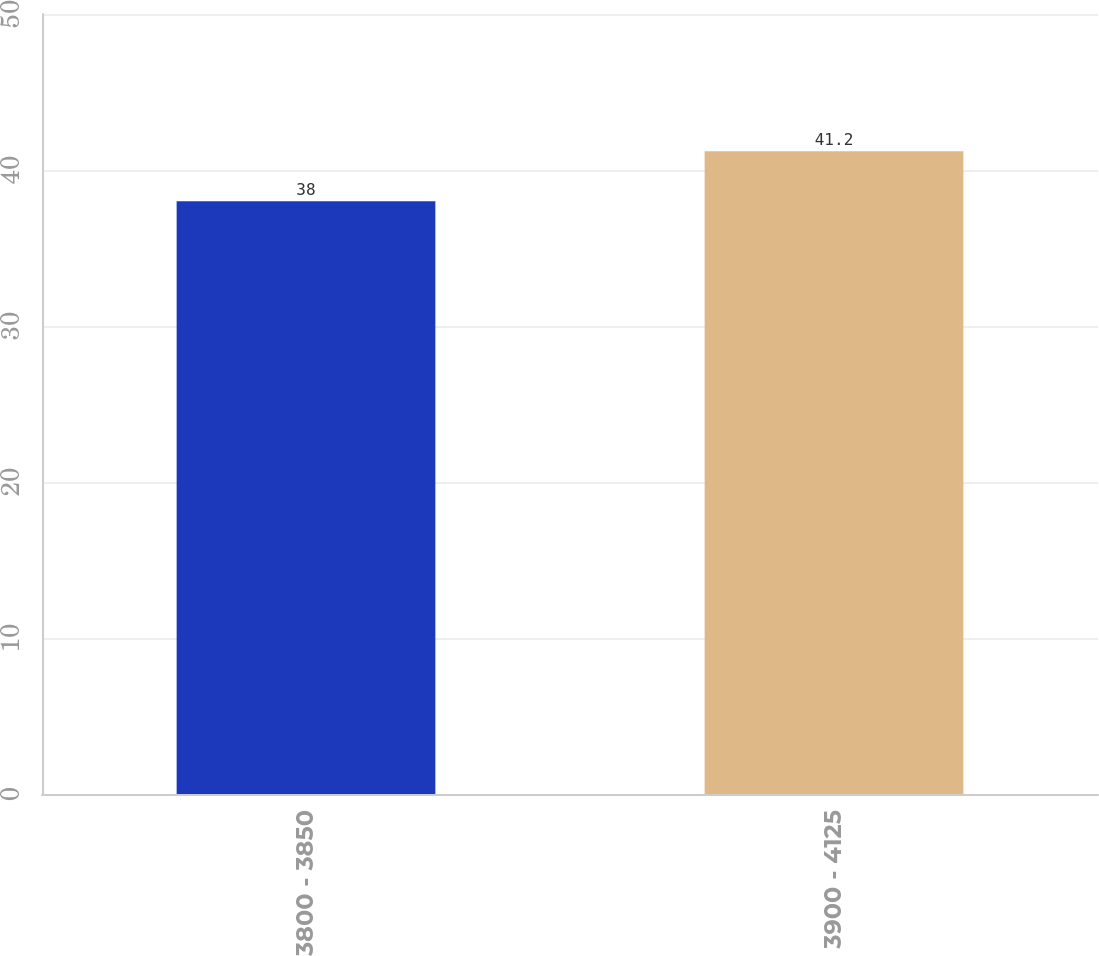Convert chart to OTSL. <chart><loc_0><loc_0><loc_500><loc_500><bar_chart><fcel>3800 - 3850<fcel>3900 - 4125<nl><fcel>38<fcel>41.2<nl></chart> 